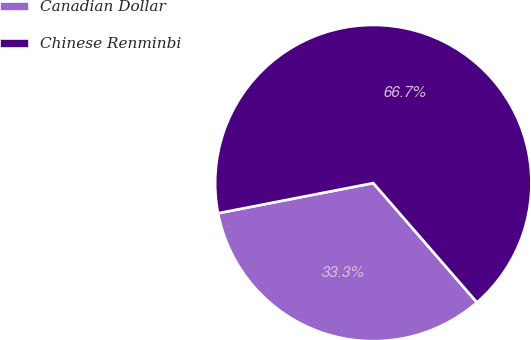Convert chart to OTSL. <chart><loc_0><loc_0><loc_500><loc_500><pie_chart><fcel>Canadian Dollar<fcel>Chinese Renminbi<nl><fcel>33.33%<fcel>66.67%<nl></chart> 